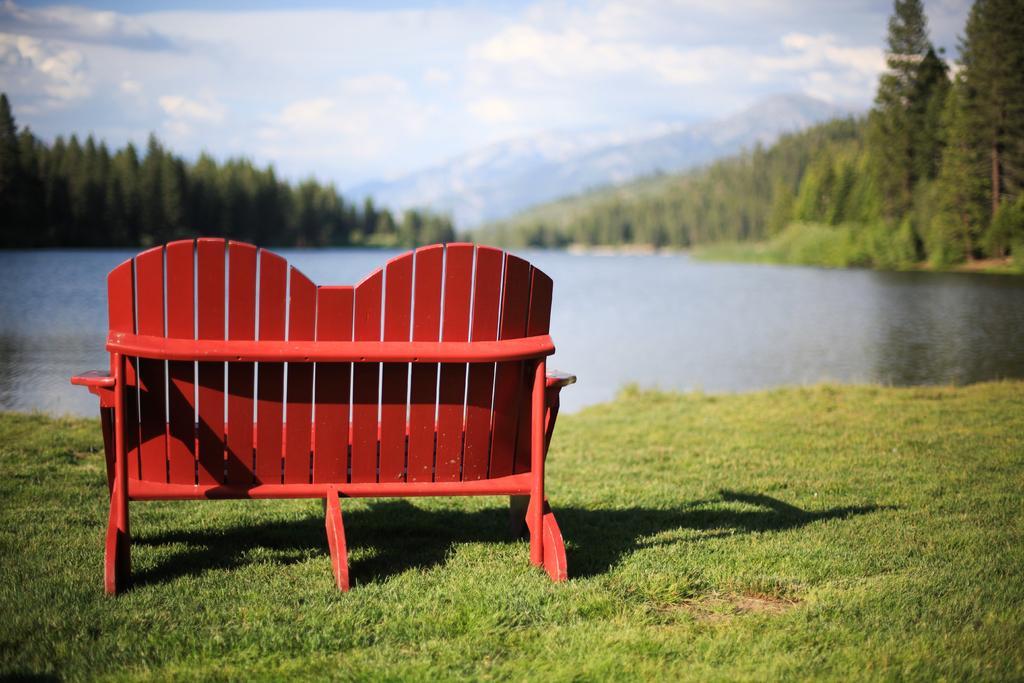In one or two sentences, can you explain what this image depicts? In this picture I can see a bench chair on the left side, there is water in the middle, there are trees on either side of this image, at the top there is the sky. 